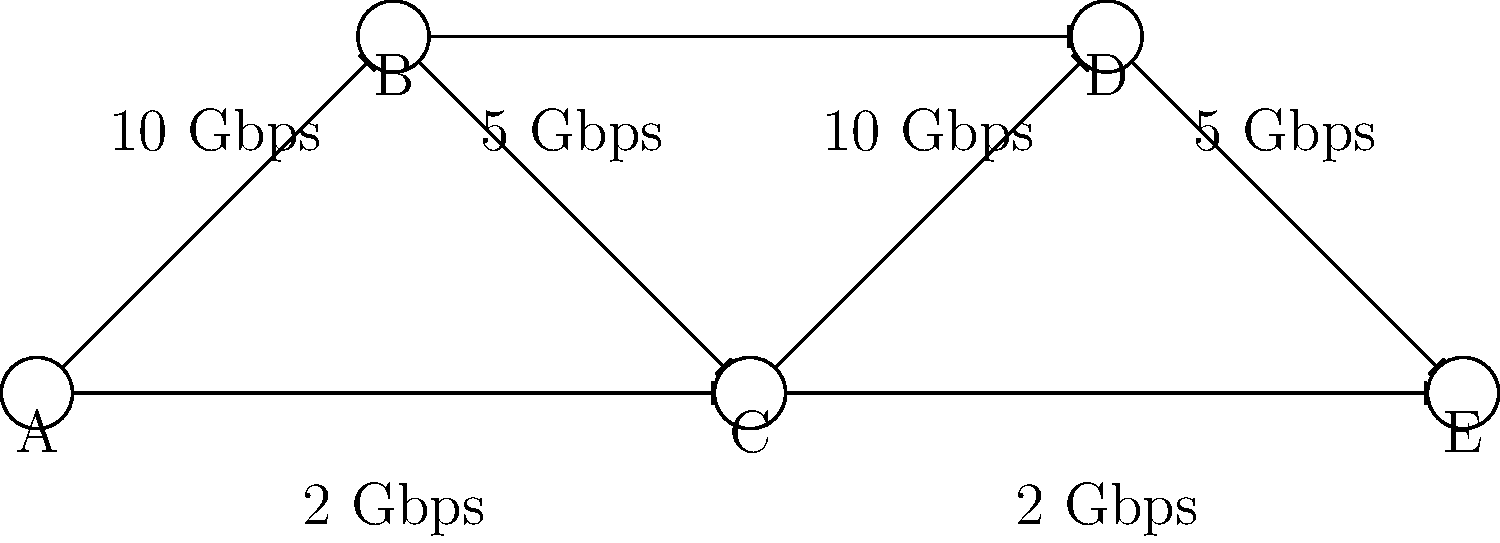In the given data center network schematic, which node represents the most likely bottleneck for data flow from node A to node E? To identify the potential bottleneck in this data center network, we need to analyze the possible paths from node A to node E and their respective bandwidths:

1. Path 1: A → B → C → D → E
   Bandwidth: min(10, 5, 10, 5) = 5 Gbps

2. Path 2: A → C → D → E
   Bandwidth: min(2, 10, 5) = 2 Gbps

3. Path 3: A → C → E
   Bandwidth: min(2, 2) = 2 Gbps

The bottleneck is the node or connection that limits the overall throughput of the network. In this case, we can see that:

1. The direct connection between A and C, as well as C and E, both have a bandwidth of 2 Gbps.
2. These connections are part of the paths with the lowest overall bandwidth (Paths 2 and 3).
3. Node C is common to both of these low-bandwidth paths.

Therefore, node C represents the most likely bottleneck for data flow from node A to node E. It's involved in both of the lowest-bandwidth paths and is connected to the network's slowest links.
Answer: Node C 